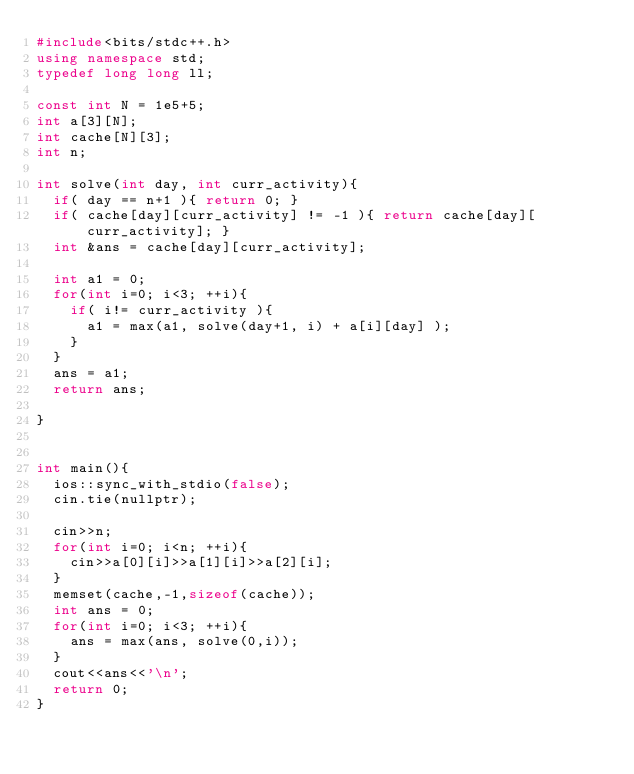Convert code to text. <code><loc_0><loc_0><loc_500><loc_500><_C++_>#include<bits/stdc++.h>
using namespace std;
typedef long long ll;

const int N = 1e5+5;
int a[3][N];
int cache[N][3];
int n;

int solve(int day, int curr_activity){
	if( day == n+1 ){ return 0; }
	if( cache[day][curr_activity] != -1 ){ return cache[day][curr_activity]; }
	int &ans = cache[day][curr_activity];

	int a1 = 0;
	for(int i=0; i<3; ++i){
		if( i!= curr_activity ){
			a1 = max(a1, solve(day+1, i) + a[i][day] );
		}
	}
	ans = a1;
	return ans;

}


int main(){
	ios::sync_with_stdio(false);
	cin.tie(nullptr);

	cin>>n;
	for(int i=0; i<n; ++i){
		cin>>a[0][i]>>a[1][i]>>a[2][i];
	}
	memset(cache,-1,sizeof(cache));
	int ans = 0;
	for(int i=0; i<3; ++i){
		ans = max(ans, solve(0,i));
	}
	cout<<ans<<'\n';
	return 0;
}
</code> 